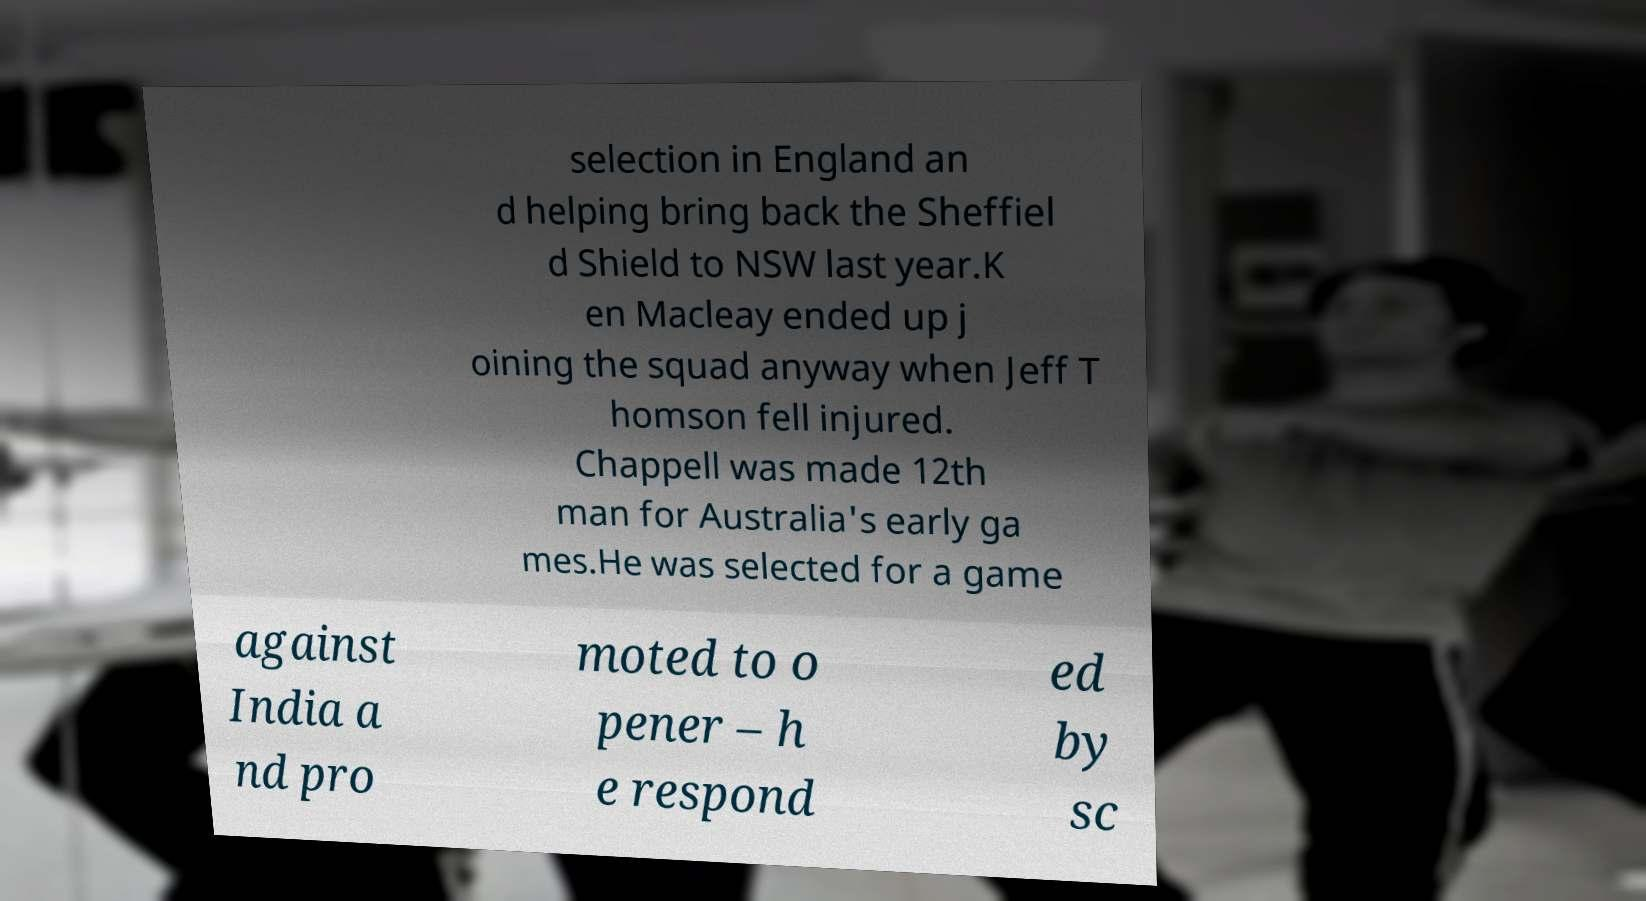What messages or text are displayed in this image? I need them in a readable, typed format. selection in England an d helping bring back the Sheffiel d Shield to NSW last year.K en Macleay ended up j oining the squad anyway when Jeff T homson fell injured. Chappell was made 12th man for Australia's early ga mes.He was selected for a game against India a nd pro moted to o pener – h e respond ed by sc 